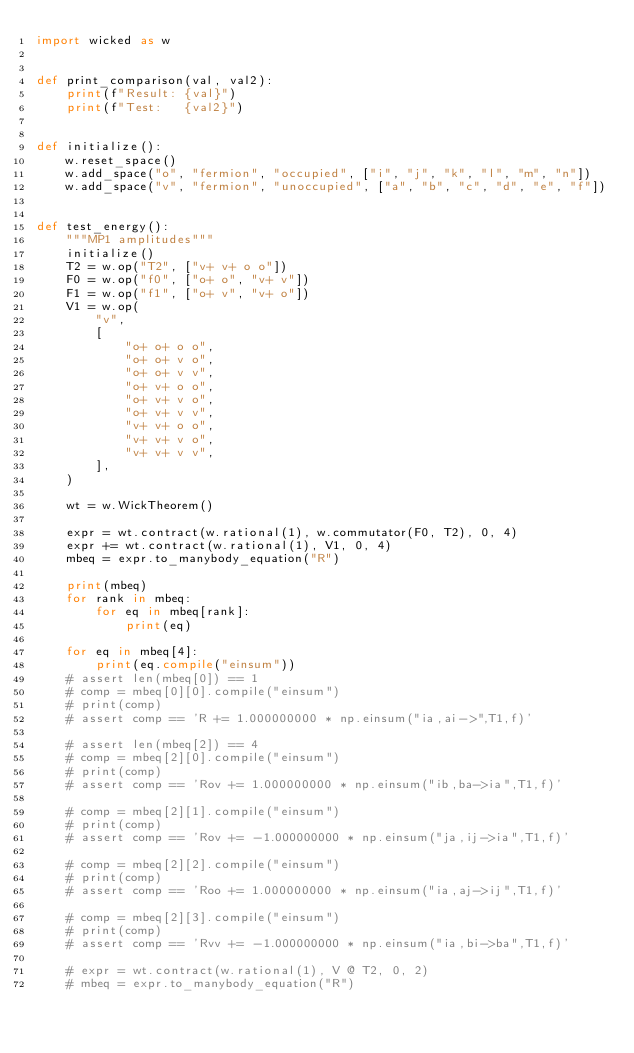<code> <loc_0><loc_0><loc_500><loc_500><_Python_>import wicked as w


def print_comparison(val, val2):
    print(f"Result: {val}")
    print(f"Test:   {val2}")


def initialize():
    w.reset_space()
    w.add_space("o", "fermion", "occupied", ["i", "j", "k", "l", "m", "n"])
    w.add_space("v", "fermion", "unoccupied", ["a", "b", "c", "d", "e", "f"])


def test_energy():
    """MP1 amplitudes"""
    initialize()
    T2 = w.op("T2", ["v+ v+ o o"])
    F0 = w.op("f0", ["o+ o", "v+ v"])
    F1 = w.op("f1", ["o+ v", "v+ o"])
    V1 = w.op(
        "v",
        [
            "o+ o+ o o",
            "o+ o+ v o",
            "o+ o+ v v",
            "o+ v+ o o",
            "o+ v+ v o",
            "o+ v+ v v",
            "v+ v+ o o",
            "v+ v+ v o",
            "v+ v+ v v",
        ],
    )

    wt = w.WickTheorem()

    expr = wt.contract(w.rational(1), w.commutator(F0, T2), 0, 4)
    expr += wt.contract(w.rational(1), V1, 0, 4)
    mbeq = expr.to_manybody_equation("R")

    print(mbeq)
    for rank in mbeq:
        for eq in mbeq[rank]:
            print(eq)

    for eq in mbeq[4]:
        print(eq.compile("einsum"))
    # assert len(mbeq[0]) == 1
    # comp = mbeq[0][0].compile("einsum")
    # print(comp)
    # assert comp == 'R += 1.000000000 * np.einsum("ia,ai->",T1,f)'

    # assert len(mbeq[2]) == 4
    # comp = mbeq[2][0].compile("einsum")
    # print(comp)
    # assert comp == 'Rov += 1.000000000 * np.einsum("ib,ba->ia",T1,f)'

    # comp = mbeq[2][1].compile("einsum")
    # print(comp)
    # assert comp == 'Rov += -1.000000000 * np.einsum("ja,ij->ia",T1,f)'

    # comp = mbeq[2][2].compile("einsum")
    # print(comp)
    # assert comp == 'Roo += 1.000000000 * np.einsum("ia,aj->ij",T1,f)'

    # comp = mbeq[2][3].compile("einsum")
    # print(comp)
    # assert comp == 'Rvv += -1.000000000 * np.einsum("ia,bi->ba",T1,f)'

    # expr = wt.contract(w.rational(1), V @ T2, 0, 2)
    # mbeq = expr.to_manybody_equation("R")
</code> 